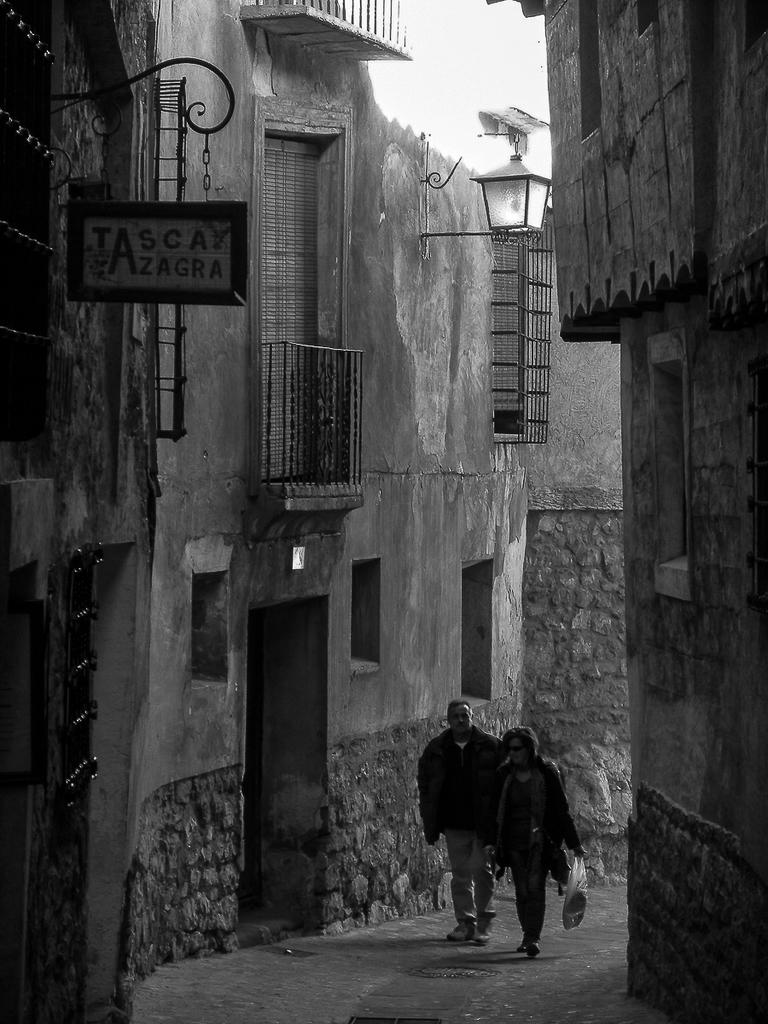What type of structures can be seen in the image? There are buildings in the image. What architectural features can be observed on the buildings? There are windows and a door visible on the buildings. What are the people in the image doing? Two people are walking in the image. What is the source of light in the image? There is a street lamp in the image. What can be seen in the sky in the image? The sky is visible in the image. Where is the cemetery located in the image? There is no cemetery present in the image. What type of field can be seen in the image? There is no field present in the image. 